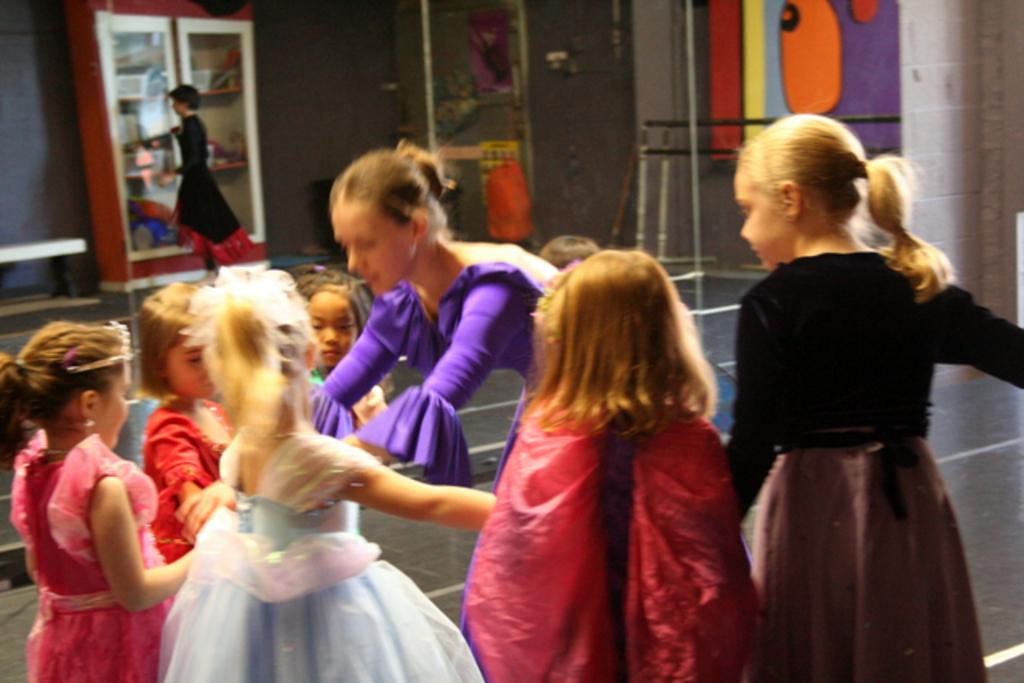What type of people can be seen in the image? There is a group of girls and women in the image. How are the girls and women positioned in the image? The girls and women are standing together in the image. What can be seen on the wall in the image? There are wall paintings in the image. What is present on the shelf in the image? There is a shelf with items in the image. What type of stick can be seen being used by the girls in the image? There is: There is no stick present in the image, and the girls are not using any sticks. 